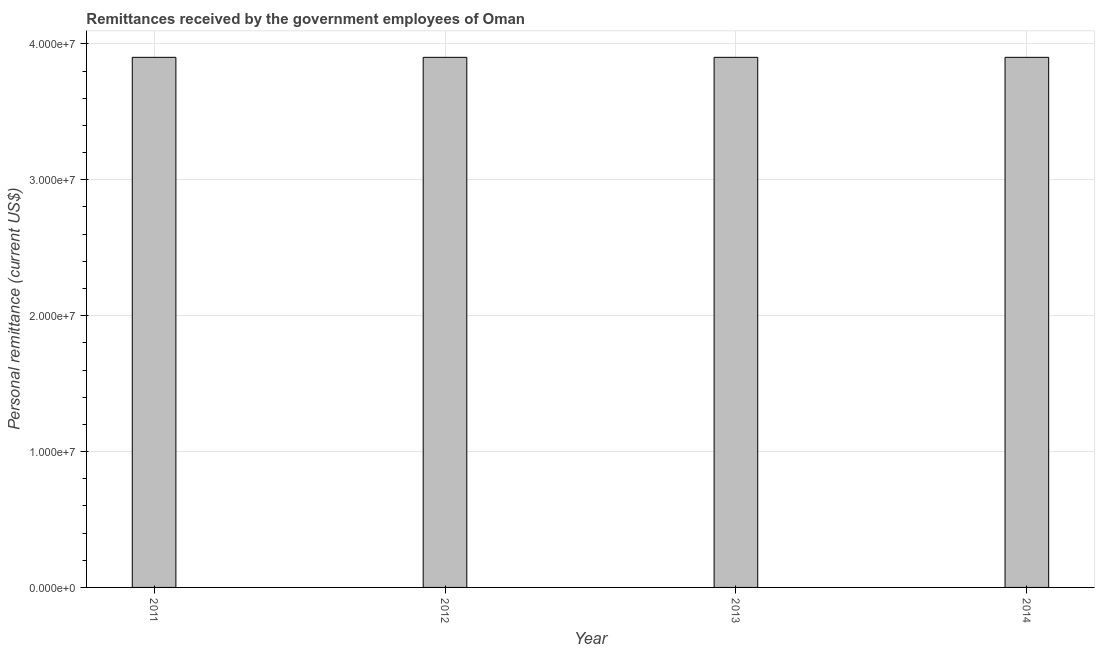What is the title of the graph?
Ensure brevity in your answer.  Remittances received by the government employees of Oman. What is the label or title of the X-axis?
Make the answer very short. Year. What is the label or title of the Y-axis?
Your answer should be very brief. Personal remittance (current US$). What is the personal remittances in 2011?
Make the answer very short. 3.90e+07. Across all years, what is the maximum personal remittances?
Provide a succinct answer. 3.90e+07. Across all years, what is the minimum personal remittances?
Offer a very short reply. 3.90e+07. In which year was the personal remittances maximum?
Your answer should be compact. 2011. What is the sum of the personal remittances?
Your answer should be compact. 1.56e+08. What is the average personal remittances per year?
Your answer should be compact. 3.90e+07. What is the median personal remittances?
Offer a very short reply. 3.90e+07. In how many years, is the personal remittances greater than 24000000 US$?
Keep it short and to the point. 4. What is the ratio of the personal remittances in 2013 to that in 2014?
Your answer should be very brief. 1. Is the personal remittances in 2011 less than that in 2013?
Your answer should be compact. No. Is the difference between the personal remittances in 2012 and 2013 greater than the difference between any two years?
Offer a very short reply. Yes. What is the difference between the highest and the second highest personal remittances?
Make the answer very short. 0. Is the sum of the personal remittances in 2012 and 2014 greater than the maximum personal remittances across all years?
Your answer should be very brief. Yes. What is the difference between the highest and the lowest personal remittances?
Make the answer very short. 0. How many bars are there?
Provide a succinct answer. 4. What is the difference between two consecutive major ticks on the Y-axis?
Your response must be concise. 1.00e+07. What is the Personal remittance (current US$) in 2011?
Offer a terse response. 3.90e+07. What is the Personal remittance (current US$) in 2012?
Offer a very short reply. 3.90e+07. What is the Personal remittance (current US$) in 2013?
Offer a very short reply. 3.90e+07. What is the Personal remittance (current US$) in 2014?
Your answer should be very brief. 3.90e+07. What is the difference between the Personal remittance (current US$) in 2011 and 2012?
Provide a succinct answer. 0. What is the difference between the Personal remittance (current US$) in 2011 and 2014?
Your answer should be compact. 0. What is the difference between the Personal remittance (current US$) in 2012 and 2013?
Provide a succinct answer. 0. What is the difference between the Personal remittance (current US$) in 2013 and 2014?
Ensure brevity in your answer.  0. What is the ratio of the Personal remittance (current US$) in 2011 to that in 2012?
Make the answer very short. 1. What is the ratio of the Personal remittance (current US$) in 2012 to that in 2014?
Provide a short and direct response. 1. What is the ratio of the Personal remittance (current US$) in 2013 to that in 2014?
Offer a terse response. 1. 